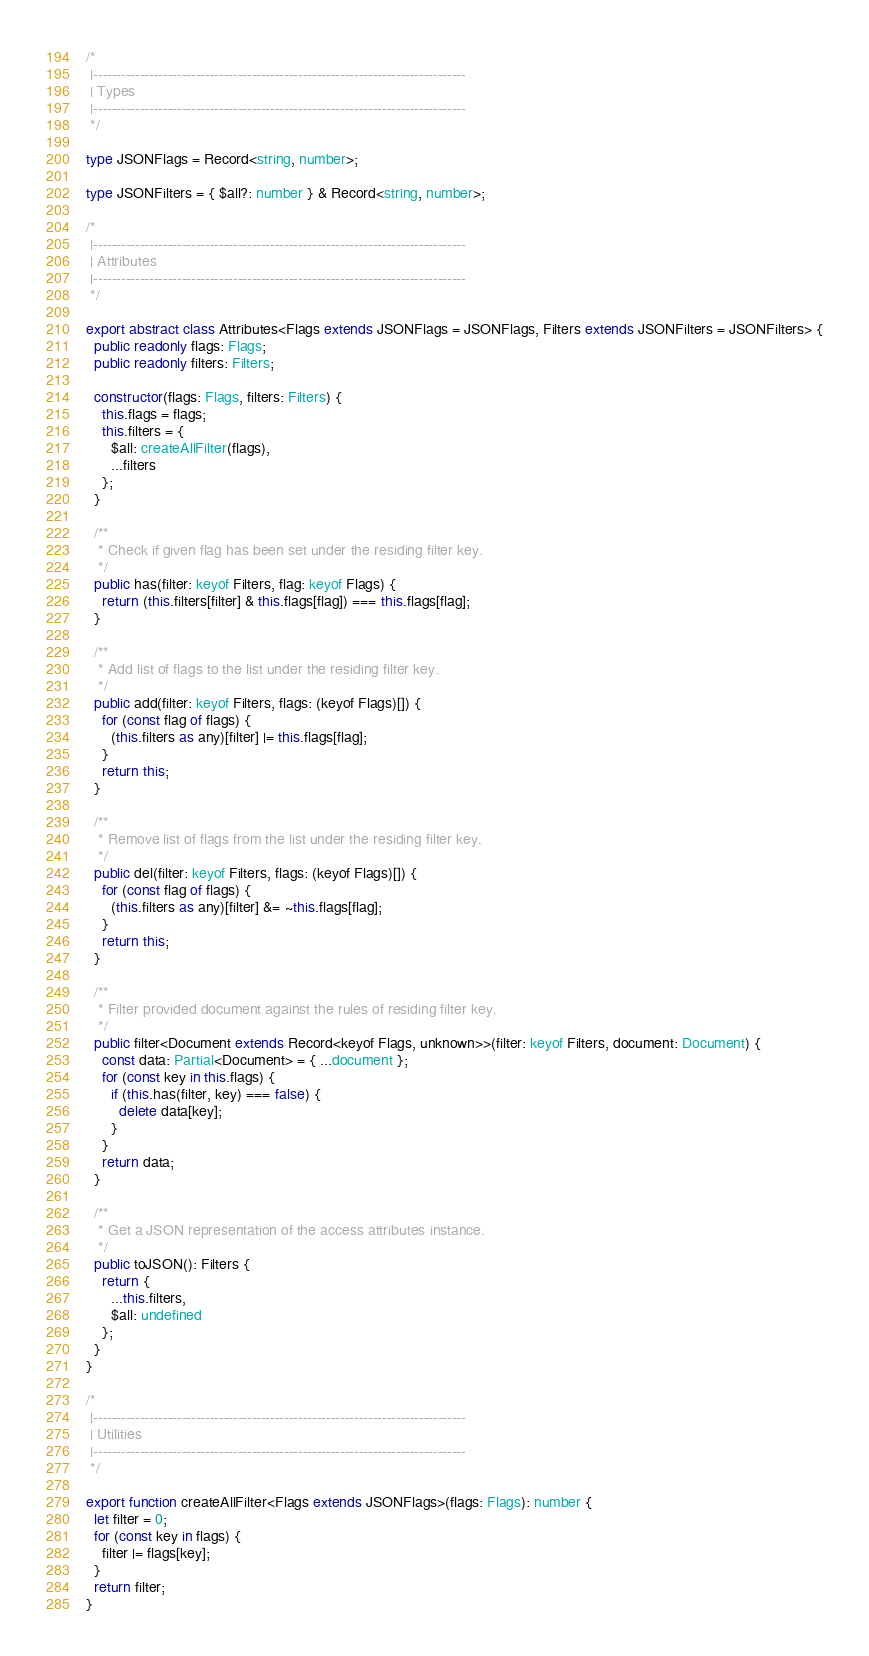<code> <loc_0><loc_0><loc_500><loc_500><_TypeScript_>/*
 |--------------------------------------------------------------------------------
 | Types
 |--------------------------------------------------------------------------------
 */

type JSONFlags = Record<string, number>;

type JSONFilters = { $all?: number } & Record<string, number>;

/*
 |--------------------------------------------------------------------------------
 | Attributes
 |--------------------------------------------------------------------------------
 */

export abstract class Attributes<Flags extends JSONFlags = JSONFlags, Filters extends JSONFilters = JSONFilters> {
  public readonly flags: Flags;
  public readonly filters: Filters;

  constructor(flags: Flags, filters: Filters) {
    this.flags = flags;
    this.filters = {
      $all: createAllFilter(flags),
      ...filters
    };
  }

  /**
   * Check if given flag has been set under the residing filter key.
   */
  public has(filter: keyof Filters, flag: keyof Flags) {
    return (this.filters[filter] & this.flags[flag]) === this.flags[flag];
  }

  /**
   * Add list of flags to the list under the residing filter key.
   */
  public add(filter: keyof Filters, flags: (keyof Flags)[]) {
    for (const flag of flags) {
      (this.filters as any)[filter] |= this.flags[flag];
    }
    return this;
  }

  /**
   * Remove list of flags from the list under the residing filter key.
   */
  public del(filter: keyof Filters, flags: (keyof Flags)[]) {
    for (const flag of flags) {
      (this.filters as any)[filter] &= ~this.flags[flag];
    }
    return this;
  }

  /**
   * Filter provided document against the rules of residing filter key.
   */
  public filter<Document extends Record<keyof Flags, unknown>>(filter: keyof Filters, document: Document) {
    const data: Partial<Document> = { ...document };
    for (const key in this.flags) {
      if (this.has(filter, key) === false) {
        delete data[key];
      }
    }
    return data;
  }

  /**
   * Get a JSON representation of the access attributes instance.
   */
  public toJSON(): Filters {
    return {
      ...this.filters,
      $all: undefined
    };
  }
}

/*
 |--------------------------------------------------------------------------------
 | Utilities
 |--------------------------------------------------------------------------------
 */

export function createAllFilter<Flags extends JSONFlags>(flags: Flags): number {
  let filter = 0;
  for (const key in flags) {
    filter |= flags[key];
  }
  return filter;
}
</code> 